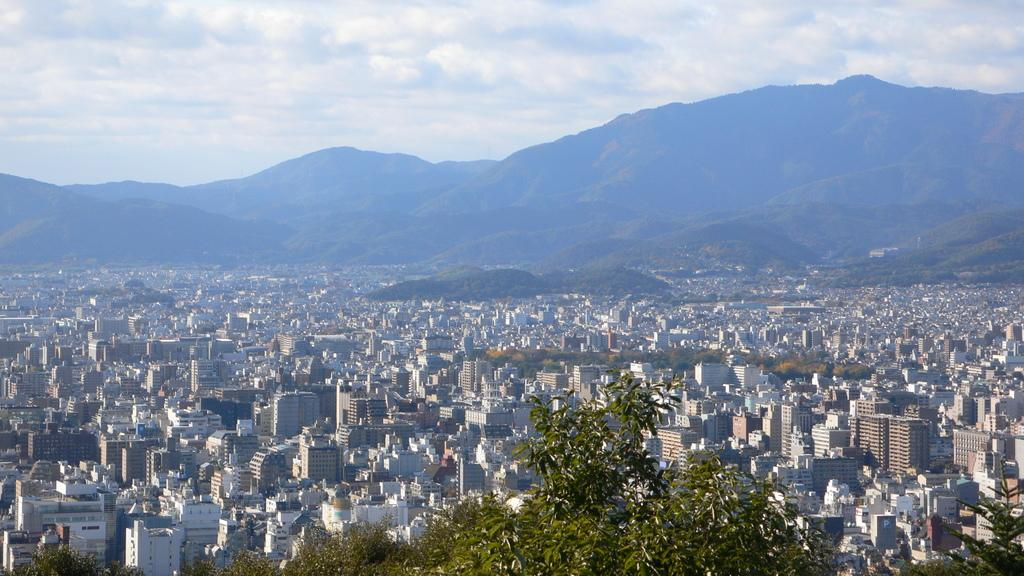What type of structures can be seen in the image? There are buildings in the image. What other natural elements are present in the image? There are trees and a hill in the image. What is visible at the top of the image? The sky is visible at the top of the image. What can be observed in the sky? Clouds are present in the sky. What is the topic of the discussion taking place on the hill in the image? There is no discussion taking place in the image; it is a still image with no audible or visible conversations. How does the friction between the trees and the hill affect the growth of the trees? The image does not provide information about the friction between the trees and the hill, nor does it show any growth or change in the trees. 